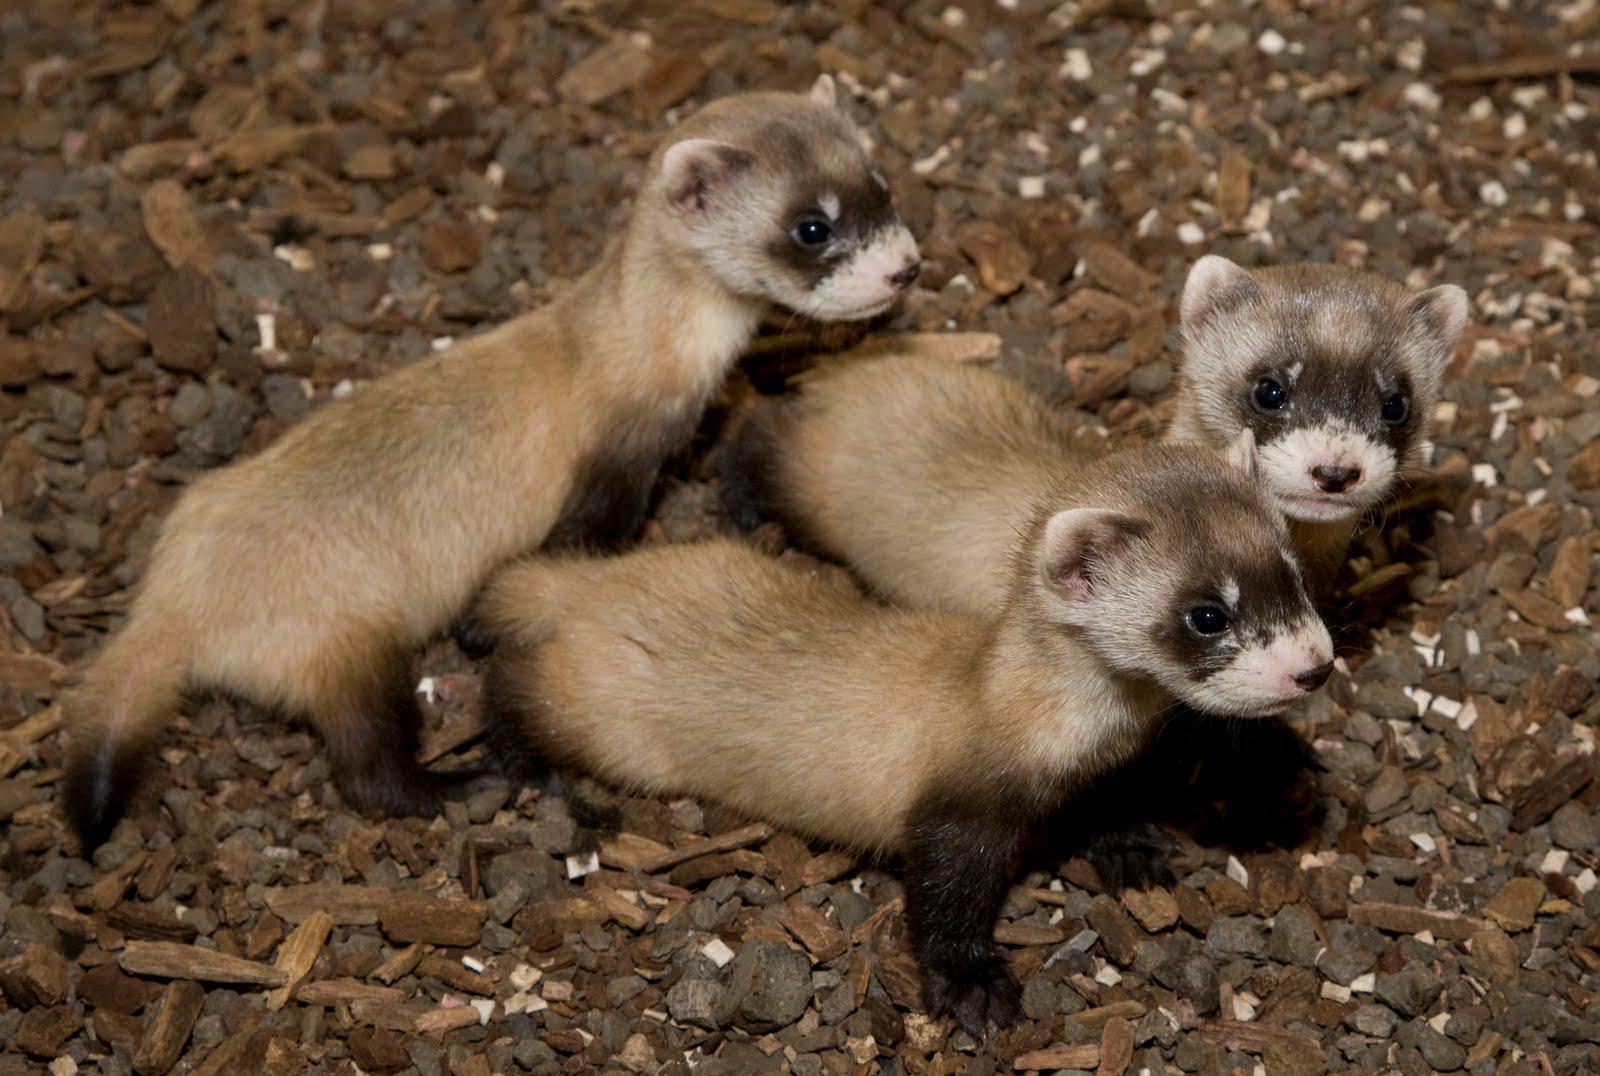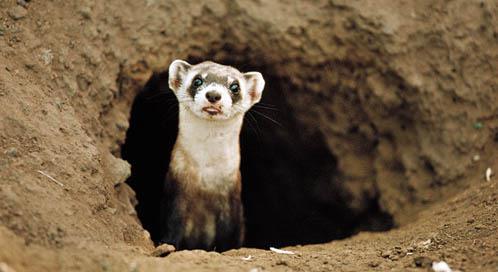The first image is the image on the left, the second image is the image on the right. Examine the images to the left and right. Is the description "There are at most four ferrets." accurate? Answer yes or no. Yes. The first image is the image on the left, the second image is the image on the right. Analyze the images presented: Is the assertion "At least one image has only one weasel." valid? Answer yes or no. Yes. 